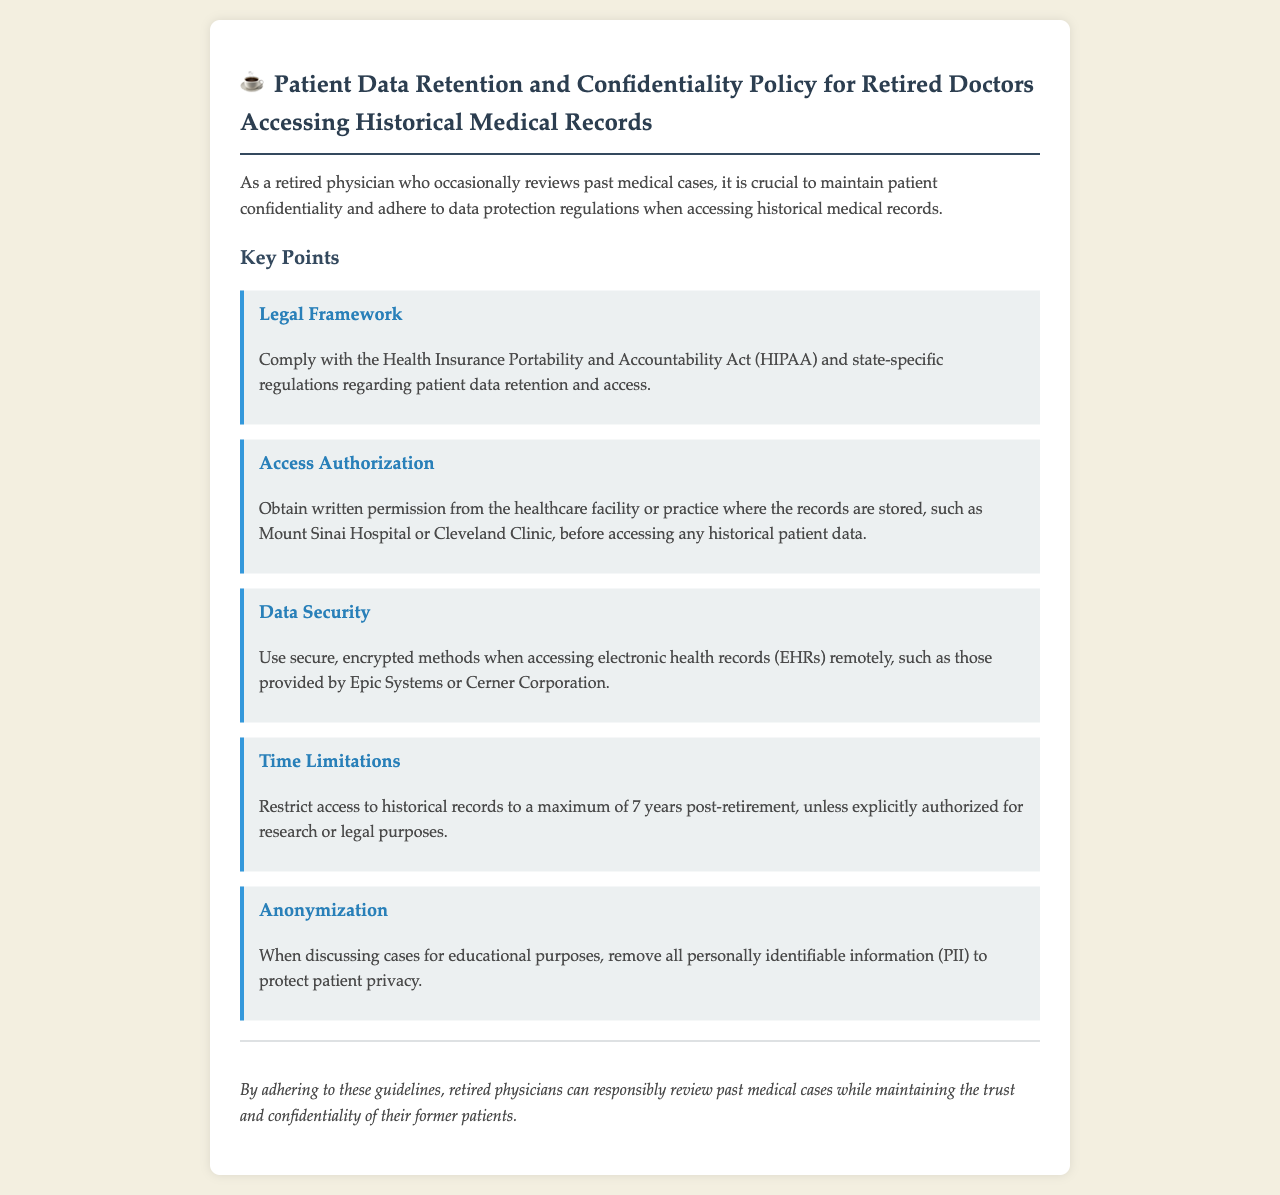What is the legal framework mentioned? The document specifies compliance with the Health Insurance Portability and Accountability Act (HIPAA) and state-specific regulations regarding patient data retention and access.
Answer: HIPAA What must be obtained to access historical patient data? The document states that one must obtain written permission from the healthcare facility or practice where the records are stored before accessing historical patient data.
Answer: Written permission How long can access to historical records be restricted? The document indicates that access to historical records is restricted to a maximum of 7 years post-retirement unless explicitly authorized for research or legal purposes.
Answer: 7 years What is recommended for data security when accessing records remotely? The document advises using secure, encrypted methods when accessing electronic health records remotely.
Answer: Encrypted methods What should be removed when discussing cases for educational purposes? The document emphasizes the removal of all personally identifiable information (PII) to protect patient privacy when discussing cases.
Answer: Personally identifiable information What type of document is this? This document outlines the rules and standards for retired doctors regarding patient data retention and confidentiality when accessing historical medical records.
Answer: Policy document What institution is mentioned as an example for record storage? The document provides Mount Sinai Hospital as an example of a healthcare facility where records may be stored.
Answer: Mount Sinai Hospital What is the main purpose of adhering to the guidelines? The document concludes that adhering to these guidelines allows retired physicians to responsibly review past medical cases while maintaining trust and confidentiality.
Answer: Maintain trust and confidentiality 